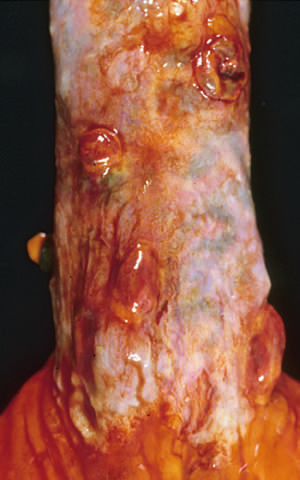re varices sites of variceal hemorrhage that were ligated with bands?
Answer the question using a single word or phrase. No 